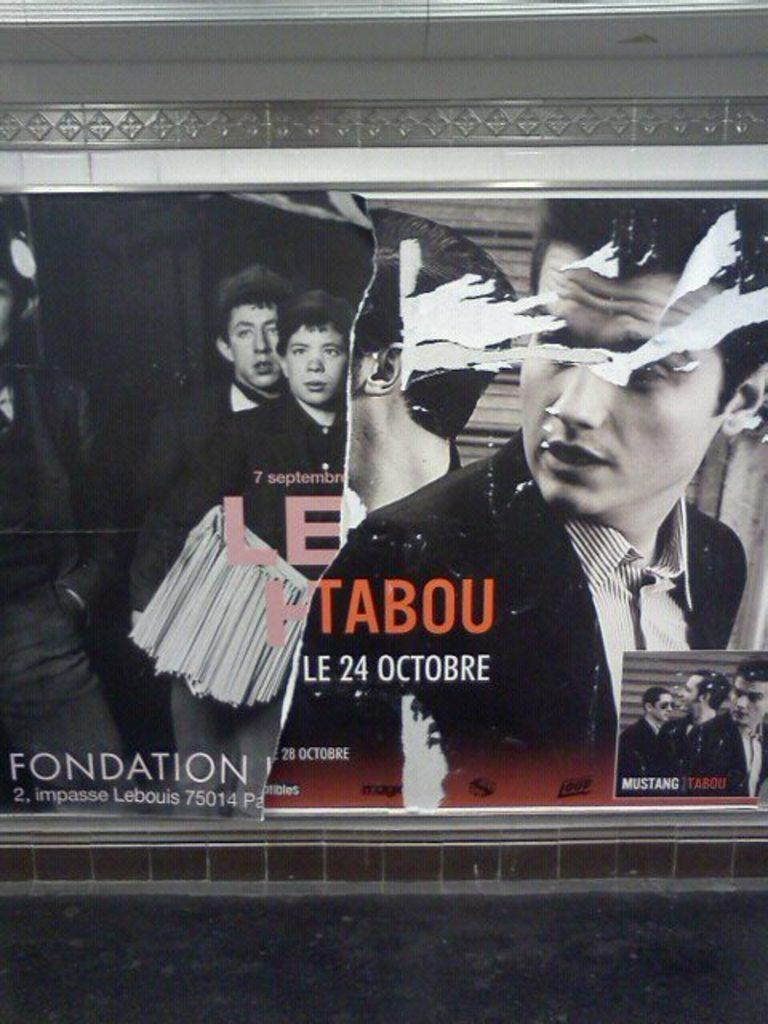What is the main object in the image? There is a poster in the image. What can be seen on the poster? The poster contains images of people and text. Where is the poster located? The poster is attached to a wall. Can you describe the detail of the friend's clothing in the image? There is no friend present in the image, only a poster with images of people. 